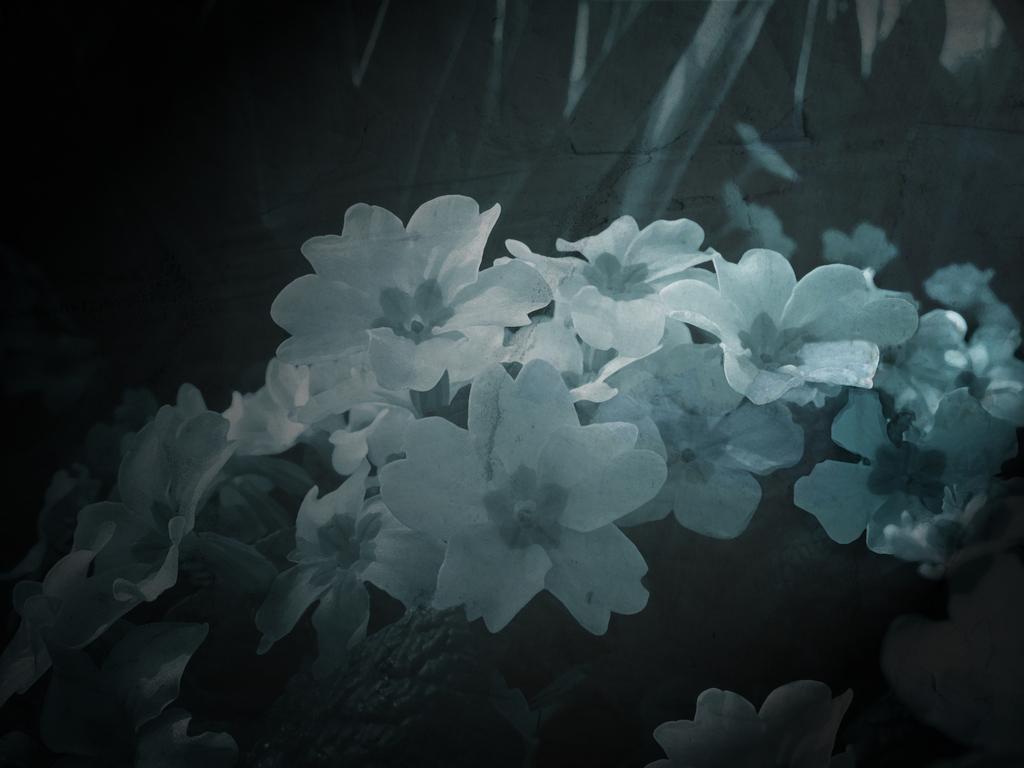In one or two sentences, can you explain what this image depicts? As we can see in the image there are white color flowers. The image is little dark. 